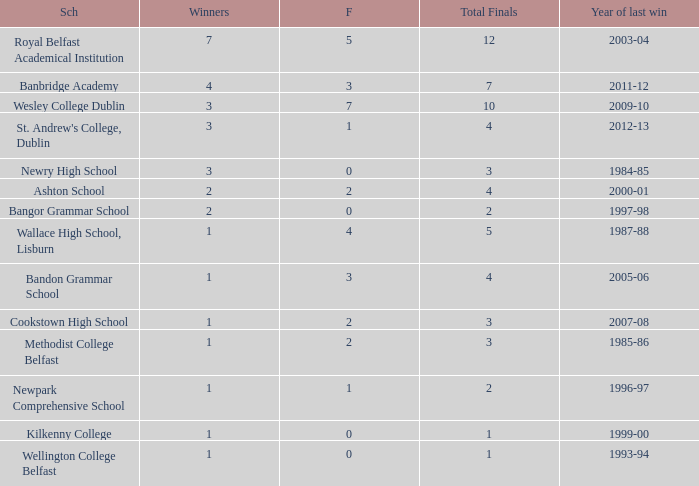Would you be able to parse every entry in this table? {'header': ['Sch', 'Winners', 'F', 'Total Finals', 'Year of last win'], 'rows': [['Royal Belfast Academical Institution', '7', '5', '12', '2003-04'], ['Banbridge Academy', '4', '3', '7', '2011-12'], ['Wesley College Dublin', '3', '7', '10', '2009-10'], ["St. Andrew's College, Dublin", '3', '1', '4', '2012-13'], ['Newry High School', '3', '0', '3', '1984-85'], ['Ashton School', '2', '2', '4', '2000-01'], ['Bangor Grammar School', '2', '0', '2', '1997-98'], ['Wallace High School, Lisburn', '1', '4', '5', '1987-88'], ['Bandon Grammar School', '1', '3', '4', '2005-06'], ['Cookstown High School', '1', '2', '3', '2007-08'], ['Methodist College Belfast', '1', '2', '3', '1985-86'], ['Newpark Comprehensive School', '1', '1', '2', '1996-97'], ['Kilkenny College', '1', '0', '1', '1999-00'], ['Wellington College Belfast', '1', '0', '1', '1993-94']]} How many total finals where there when the last win was in 2012-13? 4.0. 